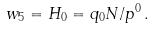<formula> <loc_0><loc_0><loc_500><loc_500>w _ { 5 } = H _ { 0 } = q _ { 0 } N / p ^ { 0 } \, .</formula> 